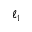Convert formula to latex. <formula><loc_0><loc_0><loc_500><loc_500>\ell _ { 1 }</formula> 